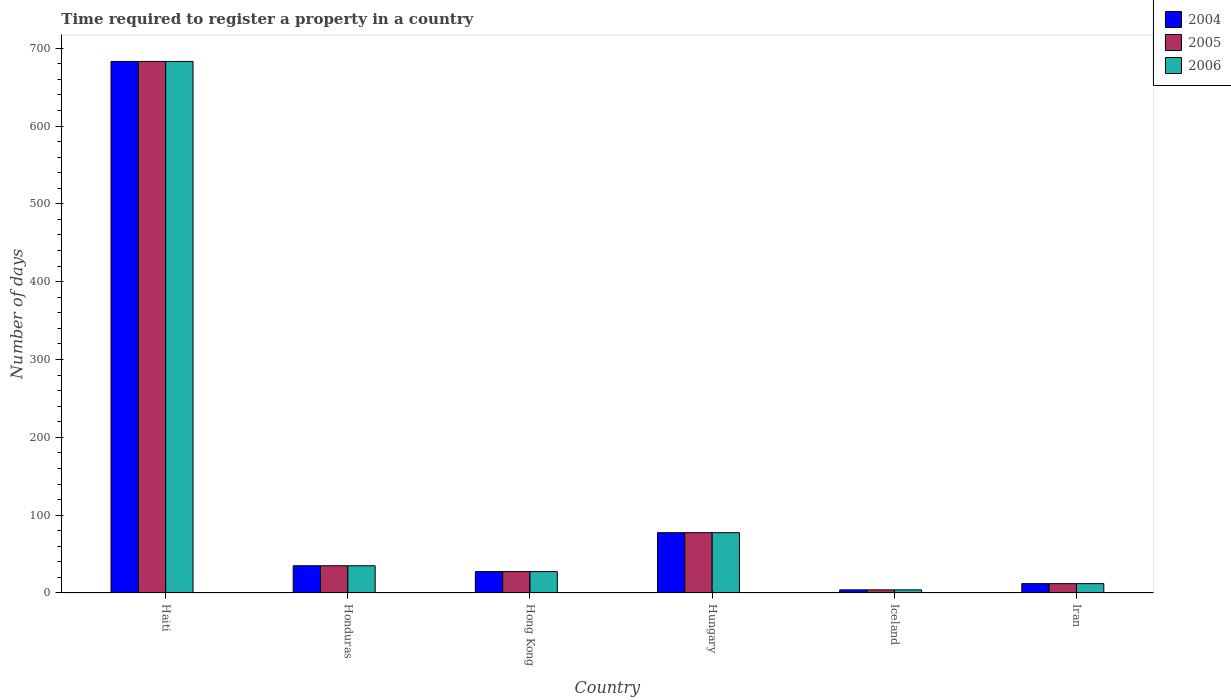What is the label of the 2nd group of bars from the left?
Provide a short and direct response. Honduras. Across all countries, what is the maximum number of days required to register a property in 2006?
Provide a succinct answer. 683. Across all countries, what is the minimum number of days required to register a property in 2004?
Make the answer very short. 4. In which country was the number of days required to register a property in 2006 maximum?
Give a very brief answer. Haiti. In which country was the number of days required to register a property in 2004 minimum?
Your response must be concise. Iceland. What is the total number of days required to register a property in 2006 in the graph?
Offer a very short reply. 839. What is the difference between the number of days required to register a property in 2006 in Haiti and that in Hong Kong?
Ensure brevity in your answer.  655.5. What is the difference between the number of days required to register a property in 2006 in Haiti and the number of days required to register a property in 2004 in Iran?
Keep it short and to the point. 671. What is the average number of days required to register a property in 2006 per country?
Keep it short and to the point. 139.83. What is the ratio of the number of days required to register a property in 2004 in Haiti to that in Hungary?
Your answer should be very brief. 8.81. Is the difference between the number of days required to register a property in 2006 in Hong Kong and Hungary greater than the difference between the number of days required to register a property in 2005 in Hong Kong and Hungary?
Provide a short and direct response. No. What is the difference between the highest and the second highest number of days required to register a property in 2006?
Provide a succinct answer. -648. What is the difference between the highest and the lowest number of days required to register a property in 2006?
Make the answer very short. 679. What does the 1st bar from the left in Iran represents?
Give a very brief answer. 2004. Is it the case that in every country, the sum of the number of days required to register a property in 2006 and number of days required to register a property in 2004 is greater than the number of days required to register a property in 2005?
Provide a short and direct response. Yes. How many countries are there in the graph?
Offer a terse response. 6. Does the graph contain grids?
Your response must be concise. No. Where does the legend appear in the graph?
Offer a terse response. Top right. What is the title of the graph?
Give a very brief answer. Time required to register a property in a country. Does "1973" appear as one of the legend labels in the graph?
Your answer should be compact. No. What is the label or title of the X-axis?
Keep it short and to the point. Country. What is the label or title of the Y-axis?
Provide a short and direct response. Number of days. What is the Number of days in 2004 in Haiti?
Ensure brevity in your answer.  683. What is the Number of days of 2005 in Haiti?
Your response must be concise. 683. What is the Number of days in 2006 in Haiti?
Provide a short and direct response. 683. What is the Number of days of 2005 in Honduras?
Give a very brief answer. 35. What is the Number of days of 2005 in Hong Kong?
Your response must be concise. 27.5. What is the Number of days in 2004 in Hungary?
Your answer should be compact. 77.5. What is the Number of days in 2005 in Hungary?
Provide a succinct answer. 77.5. What is the Number of days in 2006 in Hungary?
Your answer should be compact. 77.5. What is the Number of days in 2006 in Iran?
Offer a very short reply. 12. Across all countries, what is the maximum Number of days of 2004?
Offer a terse response. 683. Across all countries, what is the maximum Number of days of 2005?
Offer a terse response. 683. Across all countries, what is the maximum Number of days of 2006?
Provide a succinct answer. 683. What is the total Number of days of 2004 in the graph?
Offer a very short reply. 839. What is the total Number of days in 2005 in the graph?
Your answer should be very brief. 839. What is the total Number of days of 2006 in the graph?
Your response must be concise. 839. What is the difference between the Number of days of 2004 in Haiti and that in Honduras?
Your answer should be very brief. 648. What is the difference between the Number of days of 2005 in Haiti and that in Honduras?
Your answer should be very brief. 648. What is the difference between the Number of days in 2006 in Haiti and that in Honduras?
Your answer should be very brief. 648. What is the difference between the Number of days in 2004 in Haiti and that in Hong Kong?
Provide a short and direct response. 655.5. What is the difference between the Number of days in 2005 in Haiti and that in Hong Kong?
Offer a very short reply. 655.5. What is the difference between the Number of days in 2006 in Haiti and that in Hong Kong?
Offer a terse response. 655.5. What is the difference between the Number of days of 2004 in Haiti and that in Hungary?
Give a very brief answer. 605.5. What is the difference between the Number of days in 2005 in Haiti and that in Hungary?
Ensure brevity in your answer.  605.5. What is the difference between the Number of days of 2006 in Haiti and that in Hungary?
Provide a succinct answer. 605.5. What is the difference between the Number of days of 2004 in Haiti and that in Iceland?
Make the answer very short. 679. What is the difference between the Number of days of 2005 in Haiti and that in Iceland?
Your answer should be compact. 679. What is the difference between the Number of days of 2006 in Haiti and that in Iceland?
Offer a very short reply. 679. What is the difference between the Number of days in 2004 in Haiti and that in Iran?
Make the answer very short. 671. What is the difference between the Number of days in 2005 in Haiti and that in Iran?
Offer a very short reply. 671. What is the difference between the Number of days in 2006 in Haiti and that in Iran?
Your response must be concise. 671. What is the difference between the Number of days in 2004 in Honduras and that in Hong Kong?
Your response must be concise. 7.5. What is the difference between the Number of days of 2004 in Honduras and that in Hungary?
Make the answer very short. -42.5. What is the difference between the Number of days in 2005 in Honduras and that in Hungary?
Provide a succinct answer. -42.5. What is the difference between the Number of days in 2006 in Honduras and that in Hungary?
Your response must be concise. -42.5. What is the difference between the Number of days of 2004 in Honduras and that in Iceland?
Give a very brief answer. 31. What is the difference between the Number of days in 2005 in Honduras and that in Iceland?
Keep it short and to the point. 31. What is the difference between the Number of days in 2005 in Honduras and that in Iran?
Provide a short and direct response. 23. What is the difference between the Number of days of 2004 in Hong Kong and that in Hungary?
Make the answer very short. -50. What is the difference between the Number of days of 2005 in Hong Kong and that in Hungary?
Offer a terse response. -50. What is the difference between the Number of days of 2006 in Hong Kong and that in Hungary?
Provide a succinct answer. -50. What is the difference between the Number of days of 2004 in Hong Kong and that in Iceland?
Offer a terse response. 23.5. What is the difference between the Number of days in 2005 in Hong Kong and that in Iceland?
Provide a short and direct response. 23.5. What is the difference between the Number of days of 2004 in Hong Kong and that in Iran?
Your answer should be compact. 15.5. What is the difference between the Number of days of 2005 in Hong Kong and that in Iran?
Provide a short and direct response. 15.5. What is the difference between the Number of days of 2004 in Hungary and that in Iceland?
Keep it short and to the point. 73.5. What is the difference between the Number of days of 2005 in Hungary and that in Iceland?
Your answer should be very brief. 73.5. What is the difference between the Number of days of 2006 in Hungary and that in Iceland?
Provide a succinct answer. 73.5. What is the difference between the Number of days in 2004 in Hungary and that in Iran?
Your answer should be compact. 65.5. What is the difference between the Number of days of 2005 in Hungary and that in Iran?
Your response must be concise. 65.5. What is the difference between the Number of days of 2006 in Hungary and that in Iran?
Your answer should be very brief. 65.5. What is the difference between the Number of days in 2004 in Iceland and that in Iran?
Your answer should be compact. -8. What is the difference between the Number of days in 2005 in Iceland and that in Iran?
Provide a succinct answer. -8. What is the difference between the Number of days of 2006 in Iceland and that in Iran?
Provide a short and direct response. -8. What is the difference between the Number of days of 2004 in Haiti and the Number of days of 2005 in Honduras?
Keep it short and to the point. 648. What is the difference between the Number of days in 2004 in Haiti and the Number of days in 2006 in Honduras?
Keep it short and to the point. 648. What is the difference between the Number of days in 2005 in Haiti and the Number of days in 2006 in Honduras?
Offer a very short reply. 648. What is the difference between the Number of days in 2004 in Haiti and the Number of days in 2005 in Hong Kong?
Provide a short and direct response. 655.5. What is the difference between the Number of days in 2004 in Haiti and the Number of days in 2006 in Hong Kong?
Offer a very short reply. 655.5. What is the difference between the Number of days in 2005 in Haiti and the Number of days in 2006 in Hong Kong?
Give a very brief answer. 655.5. What is the difference between the Number of days in 2004 in Haiti and the Number of days in 2005 in Hungary?
Keep it short and to the point. 605.5. What is the difference between the Number of days of 2004 in Haiti and the Number of days of 2006 in Hungary?
Provide a succinct answer. 605.5. What is the difference between the Number of days in 2005 in Haiti and the Number of days in 2006 in Hungary?
Provide a succinct answer. 605.5. What is the difference between the Number of days of 2004 in Haiti and the Number of days of 2005 in Iceland?
Provide a short and direct response. 679. What is the difference between the Number of days in 2004 in Haiti and the Number of days in 2006 in Iceland?
Offer a very short reply. 679. What is the difference between the Number of days of 2005 in Haiti and the Number of days of 2006 in Iceland?
Your answer should be compact. 679. What is the difference between the Number of days of 2004 in Haiti and the Number of days of 2005 in Iran?
Your response must be concise. 671. What is the difference between the Number of days in 2004 in Haiti and the Number of days in 2006 in Iran?
Your answer should be compact. 671. What is the difference between the Number of days of 2005 in Haiti and the Number of days of 2006 in Iran?
Your response must be concise. 671. What is the difference between the Number of days of 2004 in Honduras and the Number of days of 2005 in Hong Kong?
Ensure brevity in your answer.  7.5. What is the difference between the Number of days of 2005 in Honduras and the Number of days of 2006 in Hong Kong?
Ensure brevity in your answer.  7.5. What is the difference between the Number of days of 2004 in Honduras and the Number of days of 2005 in Hungary?
Ensure brevity in your answer.  -42.5. What is the difference between the Number of days in 2004 in Honduras and the Number of days in 2006 in Hungary?
Ensure brevity in your answer.  -42.5. What is the difference between the Number of days in 2005 in Honduras and the Number of days in 2006 in Hungary?
Offer a terse response. -42.5. What is the difference between the Number of days in 2005 in Honduras and the Number of days in 2006 in Iceland?
Offer a terse response. 31. What is the difference between the Number of days in 2004 in Honduras and the Number of days in 2005 in Iran?
Provide a succinct answer. 23. What is the difference between the Number of days in 2004 in Hong Kong and the Number of days in 2005 in Iceland?
Give a very brief answer. 23.5. What is the difference between the Number of days of 2004 in Hong Kong and the Number of days of 2006 in Iran?
Give a very brief answer. 15.5. What is the difference between the Number of days in 2004 in Hungary and the Number of days in 2005 in Iceland?
Make the answer very short. 73.5. What is the difference between the Number of days of 2004 in Hungary and the Number of days of 2006 in Iceland?
Provide a short and direct response. 73.5. What is the difference between the Number of days of 2005 in Hungary and the Number of days of 2006 in Iceland?
Offer a very short reply. 73.5. What is the difference between the Number of days in 2004 in Hungary and the Number of days in 2005 in Iran?
Make the answer very short. 65.5. What is the difference between the Number of days of 2004 in Hungary and the Number of days of 2006 in Iran?
Provide a short and direct response. 65.5. What is the difference between the Number of days in 2005 in Hungary and the Number of days in 2006 in Iran?
Your answer should be very brief. 65.5. What is the difference between the Number of days in 2004 in Iceland and the Number of days in 2005 in Iran?
Ensure brevity in your answer.  -8. What is the difference between the Number of days in 2005 in Iceland and the Number of days in 2006 in Iran?
Offer a terse response. -8. What is the average Number of days of 2004 per country?
Your answer should be compact. 139.83. What is the average Number of days in 2005 per country?
Your response must be concise. 139.83. What is the average Number of days in 2006 per country?
Keep it short and to the point. 139.83. What is the difference between the Number of days in 2004 and Number of days in 2006 in Haiti?
Provide a short and direct response. 0. What is the difference between the Number of days in 2005 and Number of days in 2006 in Haiti?
Offer a very short reply. 0. What is the difference between the Number of days of 2005 and Number of days of 2006 in Honduras?
Provide a succinct answer. 0. What is the difference between the Number of days in 2004 and Number of days in 2006 in Hong Kong?
Your answer should be compact. 0. What is the difference between the Number of days of 2005 and Number of days of 2006 in Hong Kong?
Offer a terse response. 0. What is the difference between the Number of days of 2004 and Number of days of 2005 in Hungary?
Your response must be concise. 0. What is the difference between the Number of days of 2004 and Number of days of 2005 in Iceland?
Offer a very short reply. 0. What is the ratio of the Number of days in 2004 in Haiti to that in Honduras?
Your answer should be compact. 19.51. What is the ratio of the Number of days of 2005 in Haiti to that in Honduras?
Your answer should be very brief. 19.51. What is the ratio of the Number of days in 2006 in Haiti to that in Honduras?
Your answer should be compact. 19.51. What is the ratio of the Number of days in 2004 in Haiti to that in Hong Kong?
Provide a succinct answer. 24.84. What is the ratio of the Number of days of 2005 in Haiti to that in Hong Kong?
Offer a very short reply. 24.84. What is the ratio of the Number of days of 2006 in Haiti to that in Hong Kong?
Your answer should be very brief. 24.84. What is the ratio of the Number of days in 2004 in Haiti to that in Hungary?
Provide a succinct answer. 8.81. What is the ratio of the Number of days of 2005 in Haiti to that in Hungary?
Provide a succinct answer. 8.81. What is the ratio of the Number of days in 2006 in Haiti to that in Hungary?
Your answer should be very brief. 8.81. What is the ratio of the Number of days of 2004 in Haiti to that in Iceland?
Offer a terse response. 170.75. What is the ratio of the Number of days in 2005 in Haiti to that in Iceland?
Give a very brief answer. 170.75. What is the ratio of the Number of days in 2006 in Haiti to that in Iceland?
Offer a very short reply. 170.75. What is the ratio of the Number of days of 2004 in Haiti to that in Iran?
Offer a terse response. 56.92. What is the ratio of the Number of days in 2005 in Haiti to that in Iran?
Make the answer very short. 56.92. What is the ratio of the Number of days in 2006 in Haiti to that in Iran?
Your response must be concise. 56.92. What is the ratio of the Number of days in 2004 in Honduras to that in Hong Kong?
Your answer should be compact. 1.27. What is the ratio of the Number of days in 2005 in Honduras to that in Hong Kong?
Make the answer very short. 1.27. What is the ratio of the Number of days of 2006 in Honduras to that in Hong Kong?
Offer a terse response. 1.27. What is the ratio of the Number of days of 2004 in Honduras to that in Hungary?
Your answer should be compact. 0.45. What is the ratio of the Number of days of 2005 in Honduras to that in Hungary?
Your answer should be compact. 0.45. What is the ratio of the Number of days of 2006 in Honduras to that in Hungary?
Your response must be concise. 0.45. What is the ratio of the Number of days of 2004 in Honduras to that in Iceland?
Provide a succinct answer. 8.75. What is the ratio of the Number of days of 2005 in Honduras to that in Iceland?
Provide a succinct answer. 8.75. What is the ratio of the Number of days of 2006 in Honduras to that in Iceland?
Offer a very short reply. 8.75. What is the ratio of the Number of days in 2004 in Honduras to that in Iran?
Offer a terse response. 2.92. What is the ratio of the Number of days of 2005 in Honduras to that in Iran?
Your answer should be compact. 2.92. What is the ratio of the Number of days in 2006 in Honduras to that in Iran?
Offer a terse response. 2.92. What is the ratio of the Number of days in 2004 in Hong Kong to that in Hungary?
Give a very brief answer. 0.35. What is the ratio of the Number of days of 2005 in Hong Kong to that in Hungary?
Give a very brief answer. 0.35. What is the ratio of the Number of days in 2006 in Hong Kong to that in Hungary?
Make the answer very short. 0.35. What is the ratio of the Number of days in 2004 in Hong Kong to that in Iceland?
Your answer should be very brief. 6.88. What is the ratio of the Number of days of 2005 in Hong Kong to that in Iceland?
Your answer should be very brief. 6.88. What is the ratio of the Number of days in 2006 in Hong Kong to that in Iceland?
Your answer should be very brief. 6.88. What is the ratio of the Number of days in 2004 in Hong Kong to that in Iran?
Make the answer very short. 2.29. What is the ratio of the Number of days of 2005 in Hong Kong to that in Iran?
Your response must be concise. 2.29. What is the ratio of the Number of days in 2006 in Hong Kong to that in Iran?
Provide a succinct answer. 2.29. What is the ratio of the Number of days of 2004 in Hungary to that in Iceland?
Your response must be concise. 19.38. What is the ratio of the Number of days in 2005 in Hungary to that in Iceland?
Make the answer very short. 19.38. What is the ratio of the Number of days in 2006 in Hungary to that in Iceland?
Give a very brief answer. 19.38. What is the ratio of the Number of days of 2004 in Hungary to that in Iran?
Your response must be concise. 6.46. What is the ratio of the Number of days in 2005 in Hungary to that in Iran?
Your answer should be very brief. 6.46. What is the ratio of the Number of days of 2006 in Hungary to that in Iran?
Offer a very short reply. 6.46. What is the ratio of the Number of days in 2004 in Iceland to that in Iran?
Make the answer very short. 0.33. What is the ratio of the Number of days in 2005 in Iceland to that in Iran?
Provide a short and direct response. 0.33. What is the difference between the highest and the second highest Number of days in 2004?
Provide a short and direct response. 605.5. What is the difference between the highest and the second highest Number of days of 2005?
Keep it short and to the point. 605.5. What is the difference between the highest and the second highest Number of days of 2006?
Your answer should be very brief. 605.5. What is the difference between the highest and the lowest Number of days in 2004?
Your answer should be very brief. 679. What is the difference between the highest and the lowest Number of days of 2005?
Provide a succinct answer. 679. What is the difference between the highest and the lowest Number of days in 2006?
Provide a succinct answer. 679. 